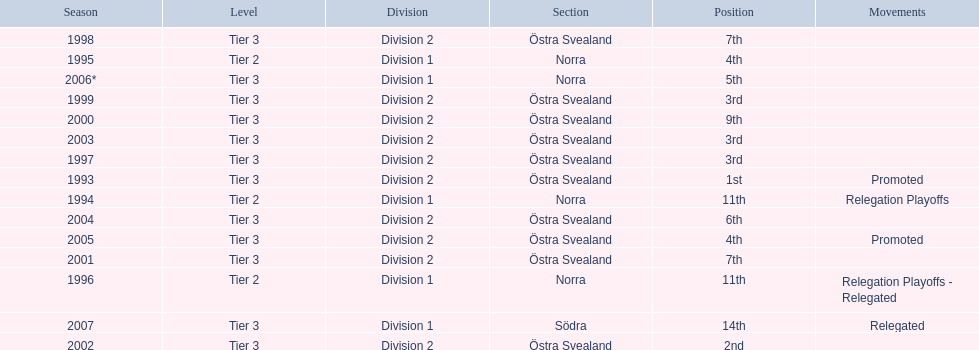Which year was more successful, 2007 or 2002? 2002. 